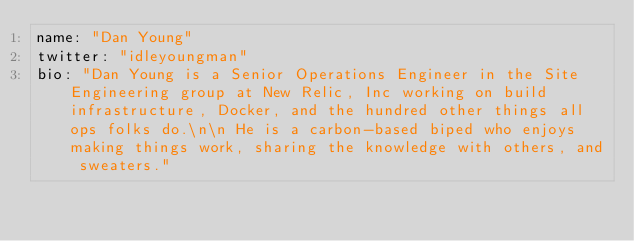<code> <loc_0><loc_0><loc_500><loc_500><_YAML_>name: "Dan Young"
twitter: "idleyoungman"
bio: "Dan Young is a Senior Operations Engineer in the Site Engineering group at New Relic, Inc working on build infrastructure, Docker, and the hundred other things all ops folks do.\n\n He is a carbon-based biped who enjoys making things work, sharing the knowledge with others, and sweaters."
</code> 